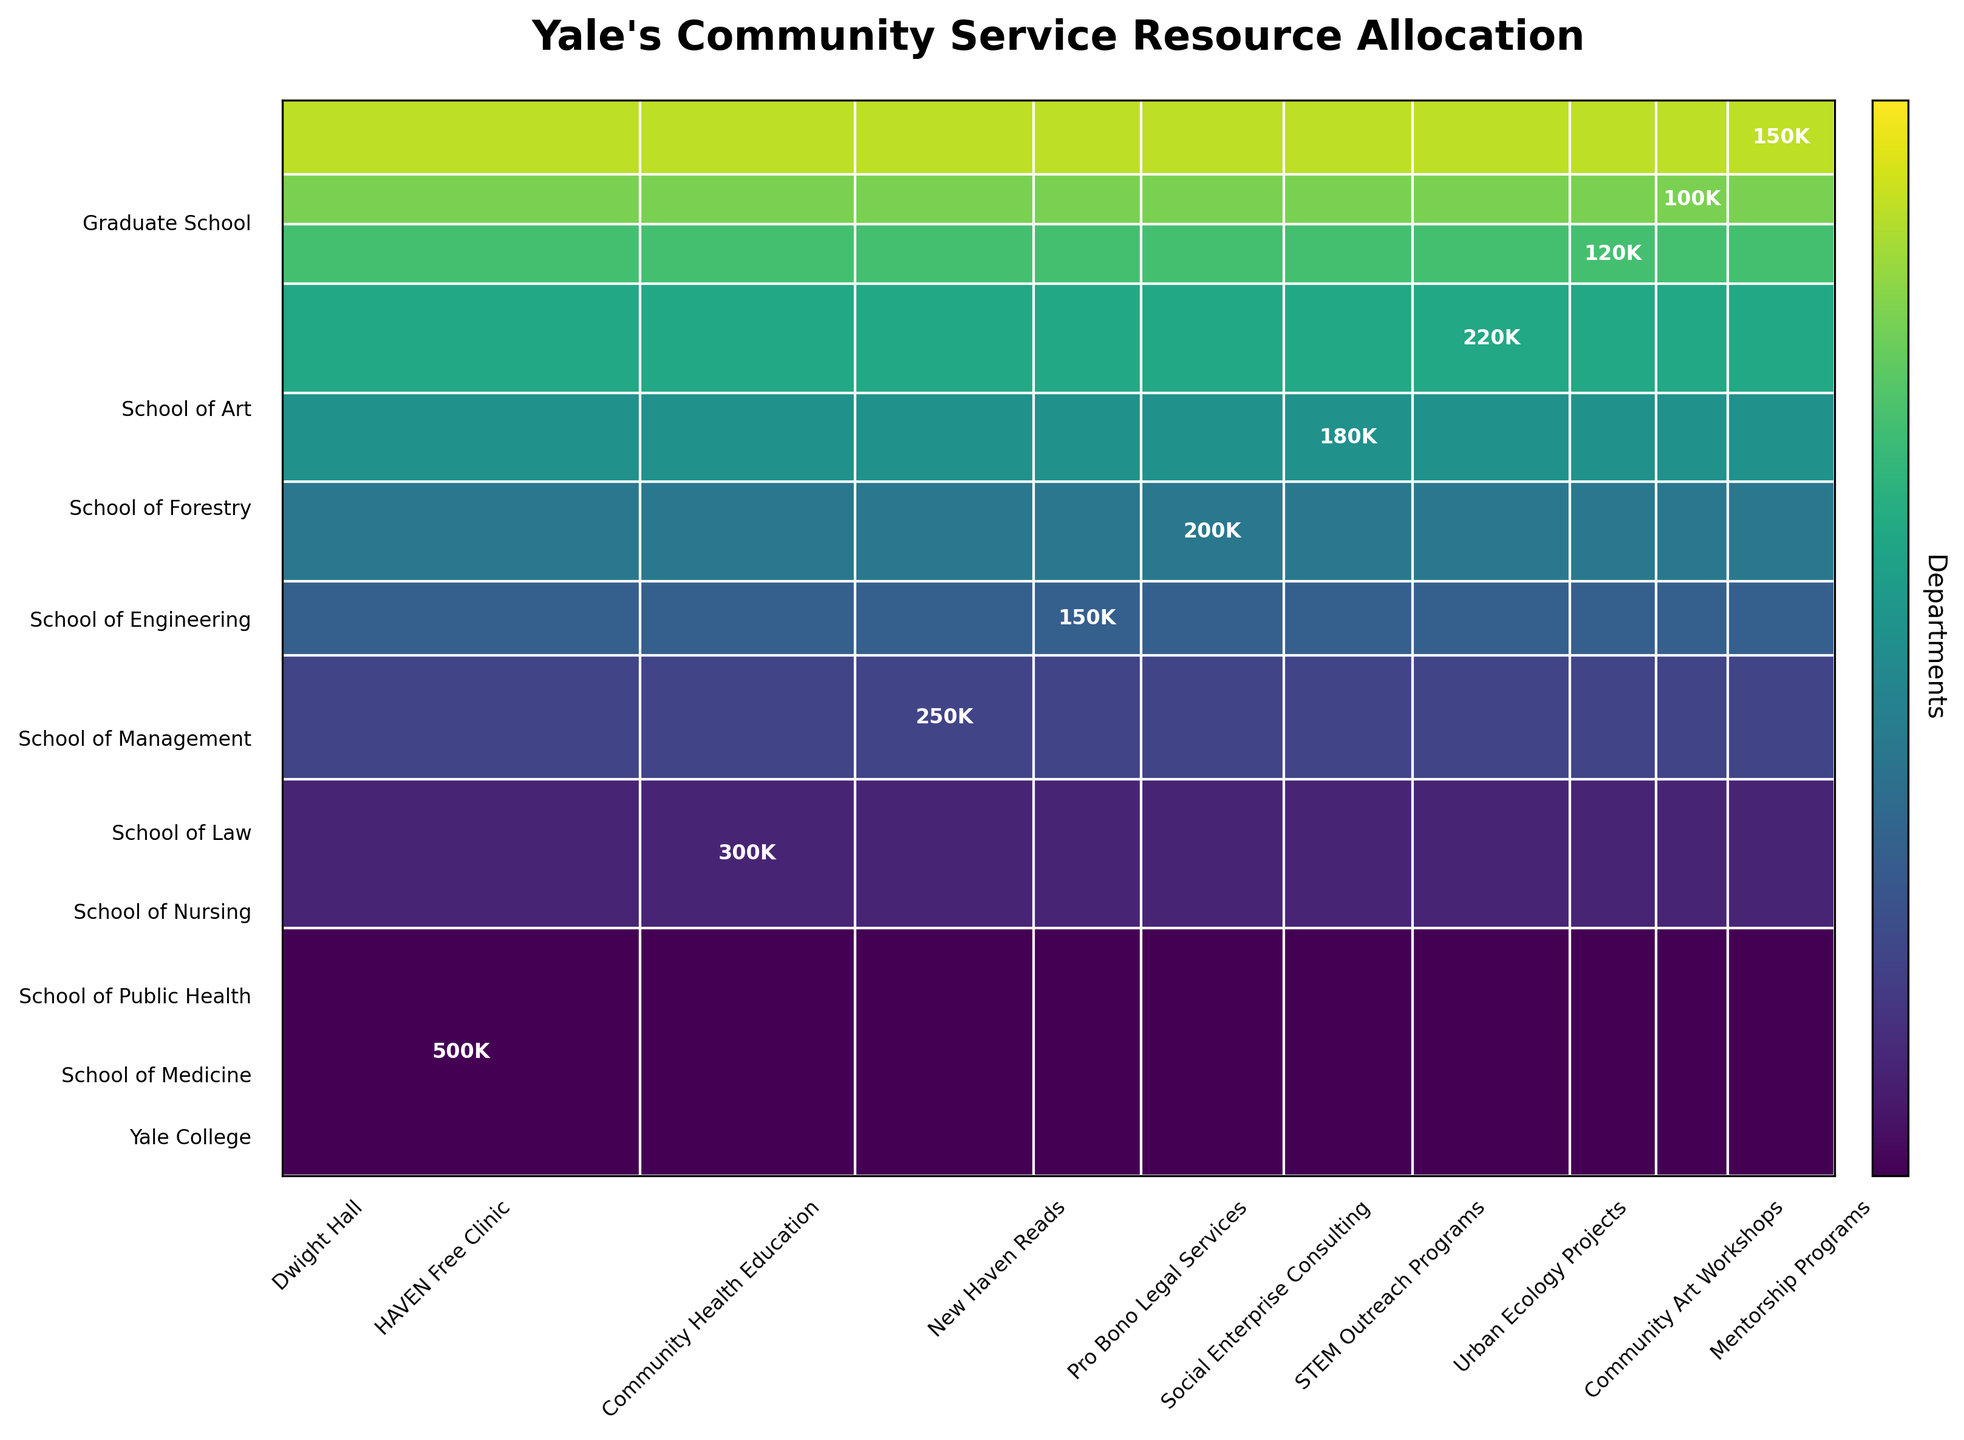What is the title of the mosaic plot? The title is written at the top of the plot and should be one of the most prominent and readable features.
Answer: Yale's Community Service Resource Allocation Which department has the highest budget allocation for community service initiatives? By looking at the vertical heights of the sections representing the departments, the department with the highest budget allocation appears largest in height.
Answer: Yale College How much more budget does Dwight Hall from Yale College receive compared to Community Art Workshops from the School of Art? First, identify the labels and numerical values in the related sections of the plot for both initiatives. Dwight Hall receives $500k and Community Art Workshops receive $100k. The difference is $500k - $100k.
Answer: $400k Which community service initiative has the smallest budget allocation? By observing the widths of the rectangles along the horizontal axis, the initiative with the smallest width represents the smallest budget allocation.
Answer: Community Art Workshops What are the budget allocations for initiatives under School of Public Health and School of Management combined? Identify the initiative sections related to these departments and sum their budget allocations. Community Health Education (School of Public Health) receives $250k, and Social Enterprise Consulting (School of Management) receives $180k. Calculate $250k + $180k.
Answer: $430k How does the budget allocation for STEM Outreach Programs compare to that for Urban Ecology Projects? Compare the numerical value, representing the budget allocation of both initiatives on the plot. STEM Outreach Programs (School of Engineering) receives $220k, while Urban Ecology Projects (School of Forestry) receives $120k.
Answer: STEM Outreach Programs has $100k more Which initiative receives the highest budget allocation, and which department does it belong to? The initiative with the highest budget allocation will be represented by the widest section horizontally in the plot. Identify the department associated with that section.
Answer: Dwight Hall from Yale College Calculate the total budget allocation for initiatives under the School of Medicine and School of Nursing. Identify the initiatives under these departments and sum their budgets. HAVEN Free Clinic (School of Medicine) receives $300k, and New Haven Reads (School of Nursing) receives $150k. Calculate $300k + $150k.
Answer: $450k 